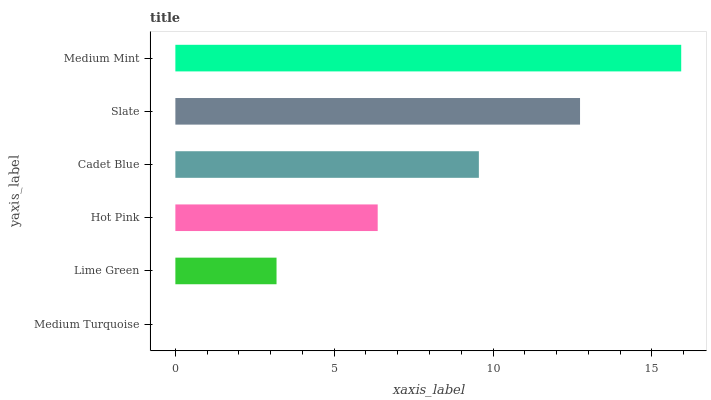Is Medium Turquoise the minimum?
Answer yes or no. Yes. Is Medium Mint the maximum?
Answer yes or no. Yes. Is Lime Green the minimum?
Answer yes or no. No. Is Lime Green the maximum?
Answer yes or no. No. Is Lime Green greater than Medium Turquoise?
Answer yes or no. Yes. Is Medium Turquoise less than Lime Green?
Answer yes or no. Yes. Is Medium Turquoise greater than Lime Green?
Answer yes or no. No. Is Lime Green less than Medium Turquoise?
Answer yes or no. No. Is Cadet Blue the high median?
Answer yes or no. Yes. Is Hot Pink the low median?
Answer yes or no. Yes. Is Lime Green the high median?
Answer yes or no. No. Is Medium Mint the low median?
Answer yes or no. No. 